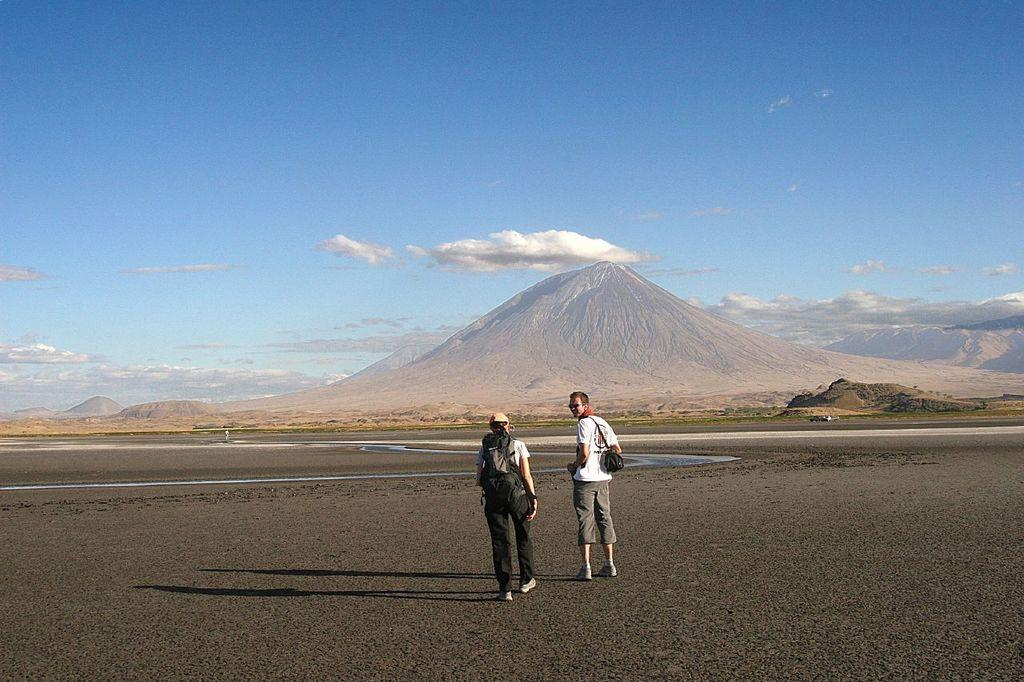What is the main subject in the center of the image? There are persons in the center of the image. What can be seen in the background of the image? There are mountains in the background of the image. What is visible in the sky in the image? Clouds are visible in the sky. What type of natural feature is visible in the image? There is water visible in the image. How does the girl perform addition in the image? There is no girl present in the image, and therefore no such activity can be observed. 